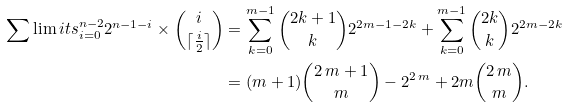Convert formula to latex. <formula><loc_0><loc_0><loc_500><loc_500>\sum \lim i t s _ { i = 0 } ^ { n - 2 } 2 ^ { n - 1 - i } \times { i \choose \lceil \frac { i } { 2 } \rceil } & = \sum _ { k = 0 } ^ { m - 1 } { 2 k + 1 \choose k } 2 ^ { 2 m - 1 - 2 k } + \sum _ { k = 0 } ^ { m - 1 } { 2 k \choose k } 2 ^ { 2 m - 2 k } \\ & = ( m + 1 ) { 2 \, m + 1 \choose m } - { 2 } ^ { 2 \, m } + 2 m { 2 \, m \choose m } .</formula> 